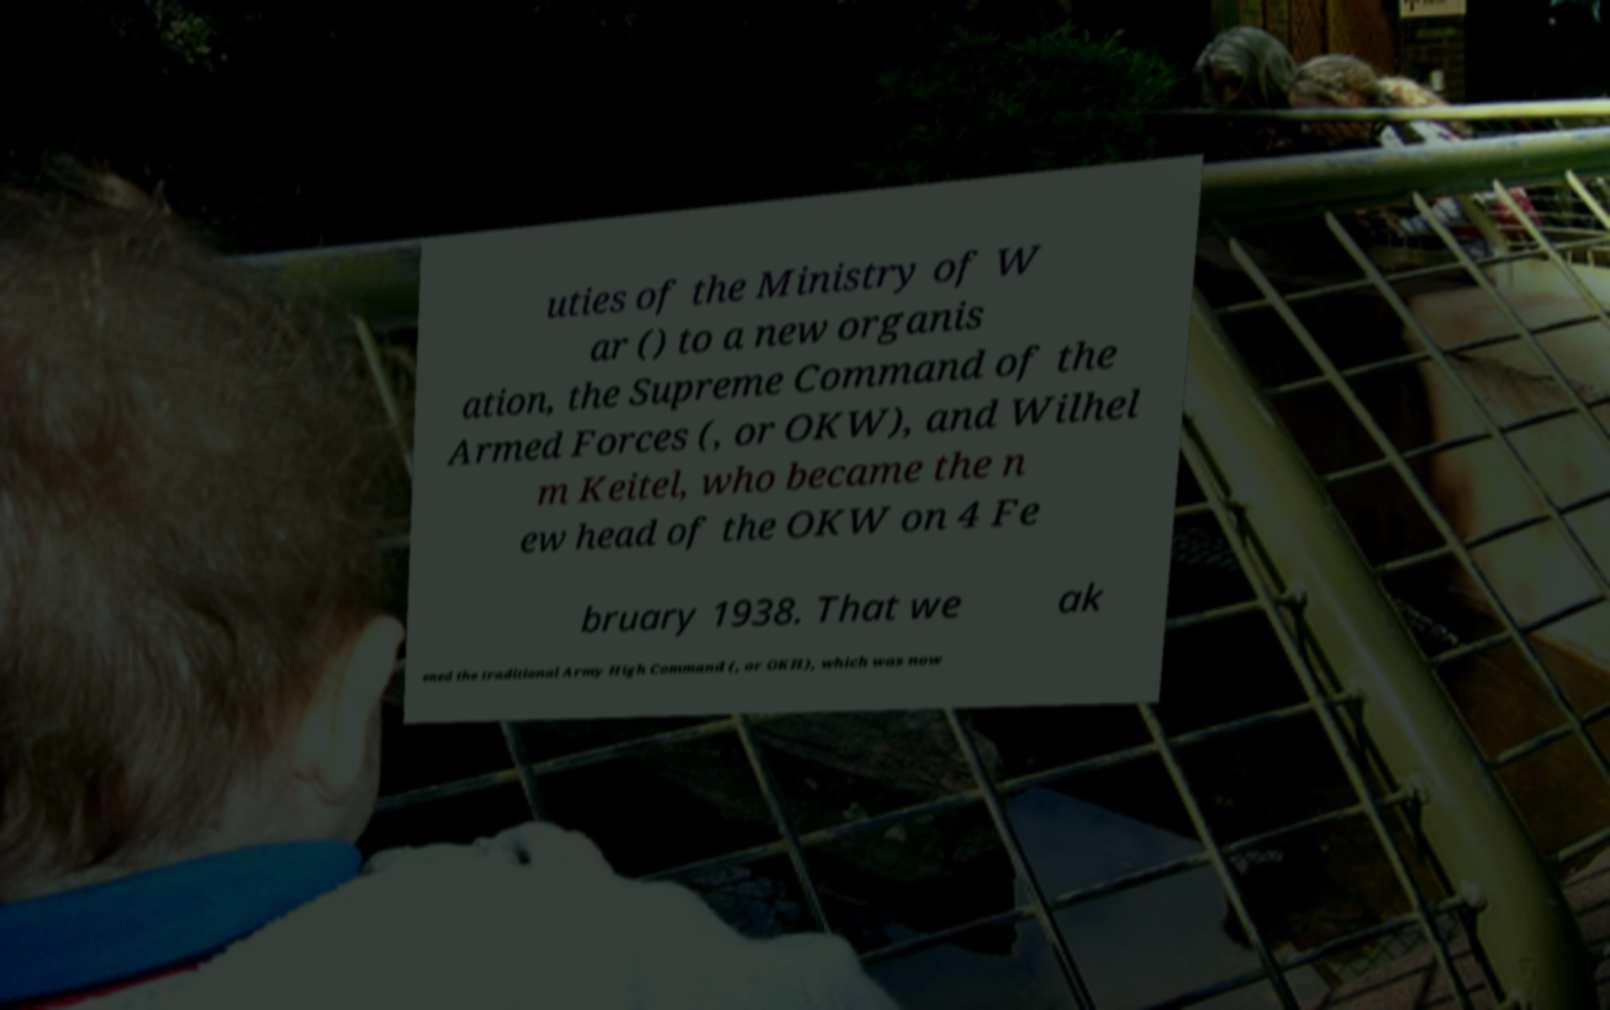Please identify and transcribe the text found in this image. uties of the Ministry of W ar () to a new organis ation, the Supreme Command of the Armed Forces (, or OKW), and Wilhel m Keitel, who became the n ew head of the OKW on 4 Fe bruary 1938. That we ak ened the traditional Army High Command (, or OKH), which was now 